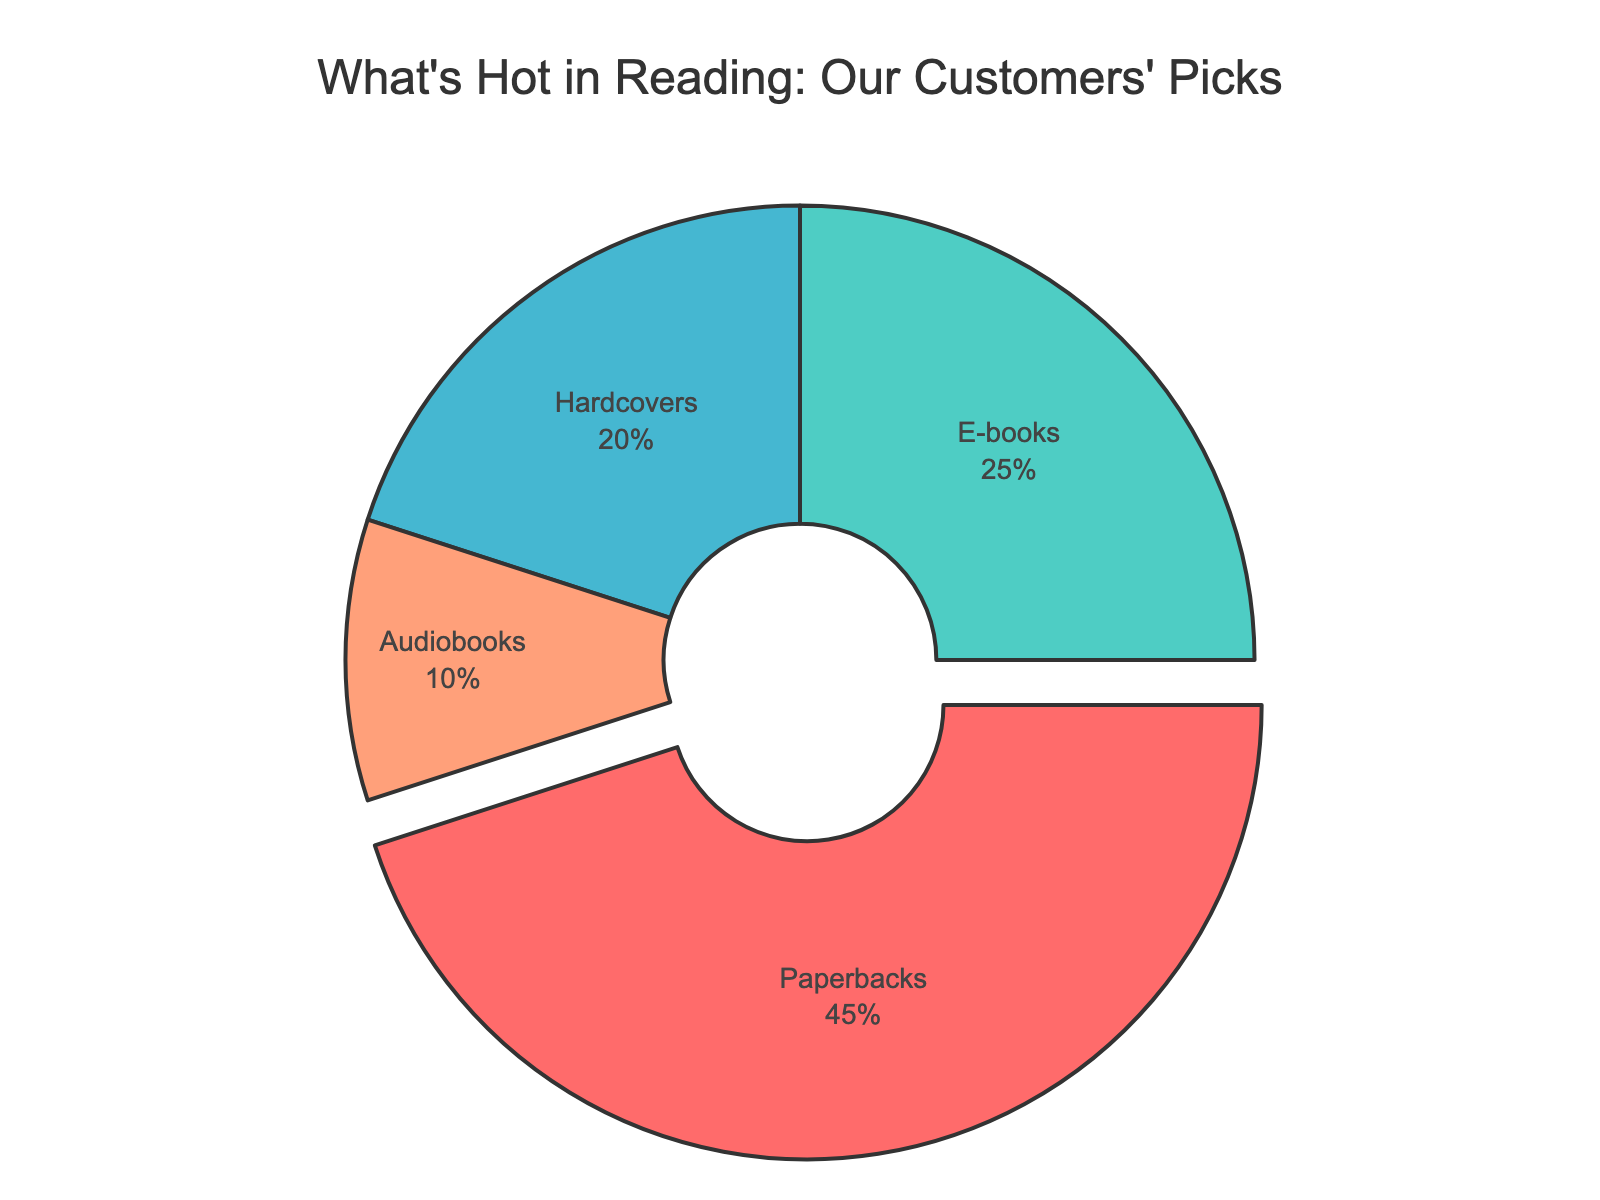What percentage of patrons prefer e-books over hardcovers? To determine the preference for e-books over hardcovers, compare their respective percentages. E-books have 25%, while hardcovers have 20%. Subtract the hardcover percentage from the e-book percentage (25% - 20% = 5%).
Answer: 5% Which format has the highest preference among store patrons? Examine the percentages of each format: Paperbacks (45%), E-books (25%), Hardcovers (20%), and Audiobooks (10%). The format with the highest percentage is paperbacks at 45%.
Answer: Paperbacks What is the total percentage of patrons who prefer either audiobooks or hardcovers? Add the percentages of patrons who prefer audiobooks and hardcovers. Audiobooks have 10%, and hardcovers have 20%. Sum these percentages (10% + 20% = 30%).
Answer: 30% How much more popular are paperbacks than audiobooks? Subtract the percentage of audiobooks from the percentage of paperbacks. Paperbacks are at 45%, and audiobooks at 10%. The difference is 45% - 10% = 35%.
Answer: 35% If the store added a new format and it achieved the same percentage as e-books, what would be the new total percentage considering all formats including the new one? The current total percentage is 100%. Adding a new format with 25% preference would result in 100% + 25% = 125%.
Answer: 125% Which format color in the chart corresponds to the least preferred format among store patrons? Identify the color associated with each format and their preferences. Audiobooks, the least preferred format at 10%, is represented by the color corresponding to that section in the pie chart (e.g., if audiobooks are visualized in orange, the correct answer is 'orange').
Answer: [orange]* Considering both e-books and paperbacks together, what percentage do they account for among the patrons' preferences? Sum the percentages of patrons preferring e-books (25%) and paperbacks (45%). The combined percentage is 25% + 45% = 70%.
Answer: 70% By how much does the preference for paperbacks exceed the combined preference for hardcovers and e-books? Add the percentages of hardcovers (20%) and e-books (25%) first, resulting in 45%. Then subtract this combined percentage from the percentage for paperbacks, which is 45%. The difference is 45% - 45% = 0%.
Answer: 0% If the audiobooks percentage doubled, what would it be and would it surpass the hardcovers' percentage? Double the current percentage of audiobooks: 10% * 2 = 20%. Then, compare it to the hardcovers' percentage, which is 20%. Since 20% is equal to 20%, audiobooks would match but not surpass hardcovers.
Answer: 20%, No 